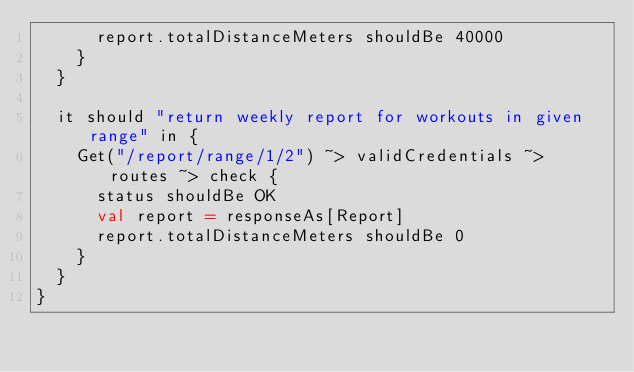<code> <loc_0><loc_0><loc_500><loc_500><_Scala_>      report.totalDistanceMeters shouldBe 40000
    }
  }

  it should "return weekly report for workouts in given range" in {
    Get("/report/range/1/2") ~> validCredentials ~> routes ~> check {
      status shouldBe OK
      val report = responseAs[Report]
      report.totalDistanceMeters shouldBe 0
    }
  }
}
</code> 